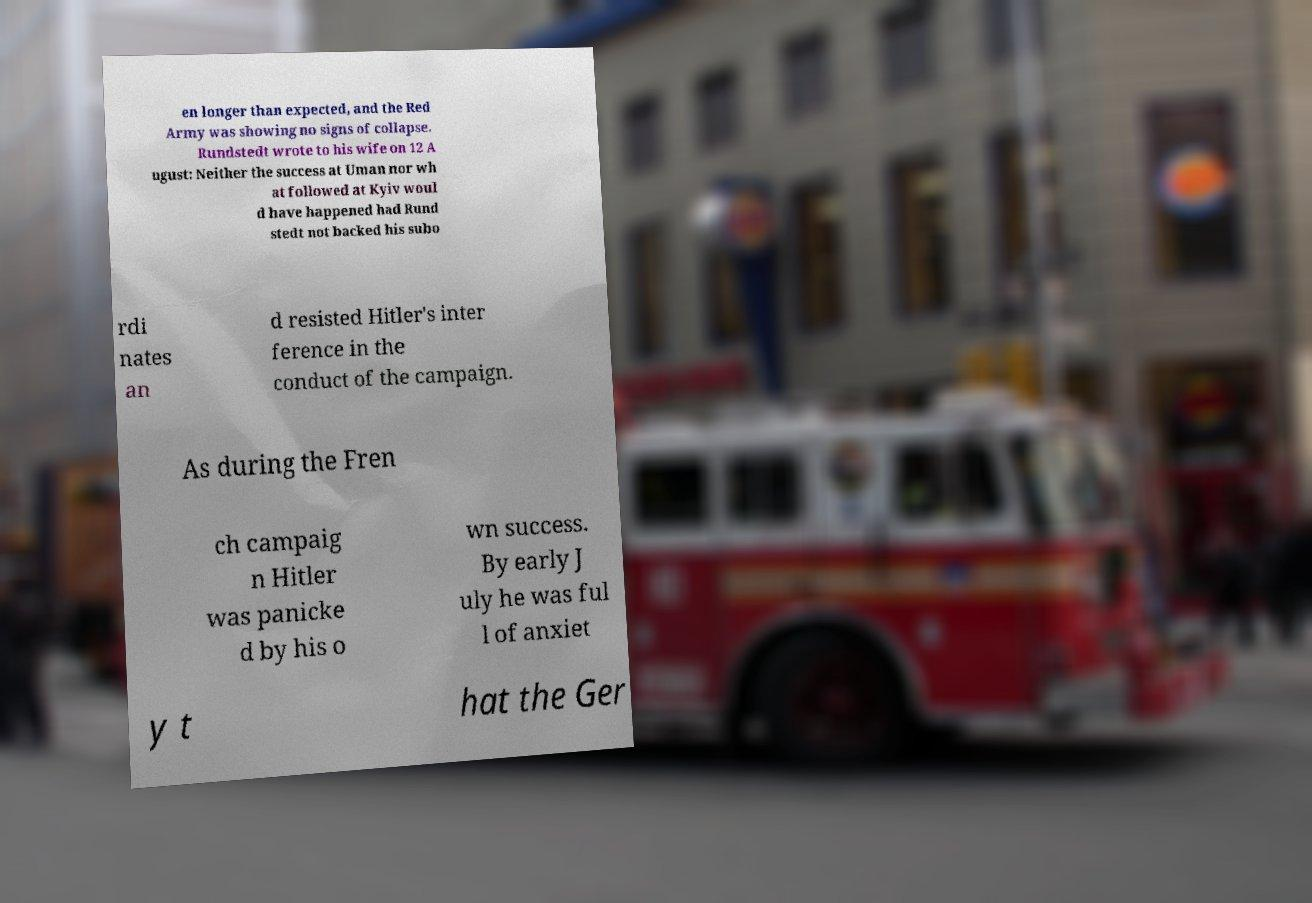Please identify and transcribe the text found in this image. en longer than expected, and the Red Army was showing no signs of collapse. Rundstedt wrote to his wife on 12 A ugust: Neither the success at Uman nor wh at followed at Kyiv woul d have happened had Rund stedt not backed his subo rdi nates an d resisted Hitler's inter ference in the conduct of the campaign. As during the Fren ch campaig n Hitler was panicke d by his o wn success. By early J uly he was ful l of anxiet y t hat the Ger 